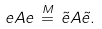<formula> <loc_0><loc_0><loc_500><loc_500>e A e \, \stackrel { M } { = } \, \tilde { e } A \tilde { e } .</formula> 